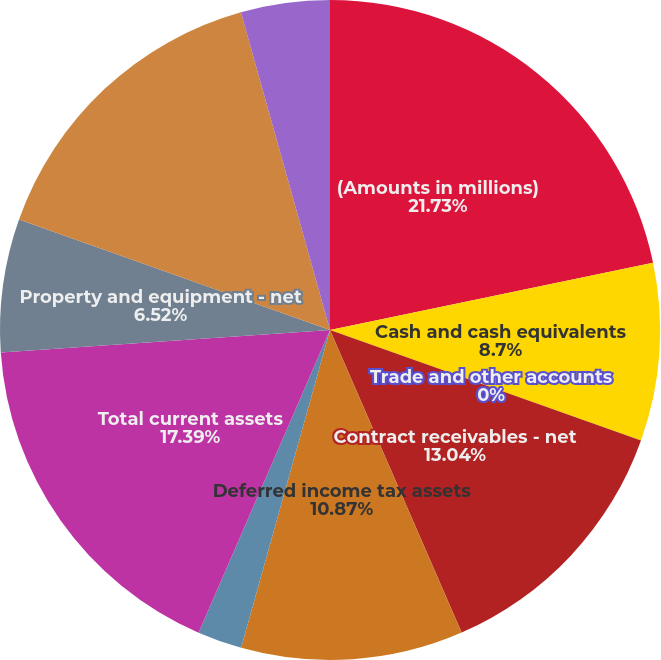<chart> <loc_0><loc_0><loc_500><loc_500><pie_chart><fcel>(Amounts in millions)<fcel>Cash and cash equivalents<fcel>Trade and other accounts<fcel>Contract receivables - net<fcel>Deferred income tax assets<fcel>Prepaid expenses and other<fcel>Total current assets<fcel>Property and equipment - net<fcel>Long-term contract receivables<fcel>Other assets<nl><fcel>21.73%<fcel>8.7%<fcel>0.0%<fcel>13.04%<fcel>10.87%<fcel>2.18%<fcel>17.39%<fcel>6.52%<fcel>15.22%<fcel>4.35%<nl></chart> 